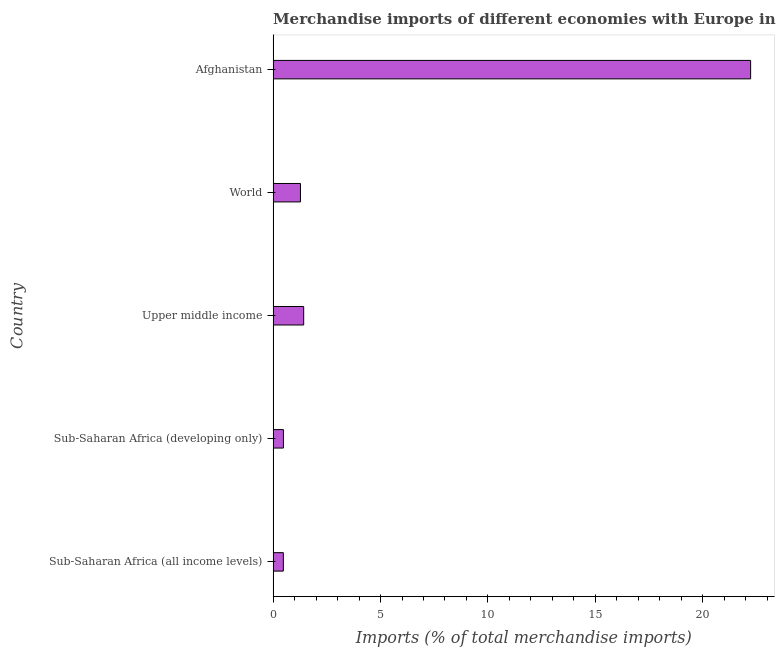Does the graph contain grids?
Provide a short and direct response. No. What is the title of the graph?
Your answer should be very brief. Merchandise imports of different economies with Europe in 2000. What is the label or title of the X-axis?
Your response must be concise. Imports (% of total merchandise imports). What is the merchandise imports in Sub-Saharan Africa (developing only)?
Offer a very short reply. 0.48. Across all countries, what is the maximum merchandise imports?
Your answer should be very brief. 22.23. Across all countries, what is the minimum merchandise imports?
Offer a terse response. 0.48. In which country was the merchandise imports maximum?
Keep it short and to the point. Afghanistan. In which country was the merchandise imports minimum?
Your response must be concise. Sub-Saharan Africa (all income levels). What is the sum of the merchandise imports?
Keep it short and to the point. 25.88. What is the difference between the merchandise imports in Sub-Saharan Africa (developing only) and Upper middle income?
Give a very brief answer. -0.94. What is the average merchandise imports per country?
Your answer should be very brief. 5.18. What is the median merchandise imports?
Make the answer very short. 1.27. In how many countries, is the merchandise imports greater than 13 %?
Provide a short and direct response. 1. What is the ratio of the merchandise imports in Afghanistan to that in World?
Make the answer very short. 17.47. Is the merchandise imports in Sub-Saharan Africa (developing only) less than that in Upper middle income?
Your response must be concise. Yes. Is the difference between the merchandise imports in Sub-Saharan Africa (developing only) and World greater than the difference between any two countries?
Offer a very short reply. No. What is the difference between the highest and the second highest merchandise imports?
Provide a short and direct response. 20.81. What is the difference between the highest and the lowest merchandise imports?
Keep it short and to the point. 21.75. In how many countries, is the merchandise imports greater than the average merchandise imports taken over all countries?
Offer a very short reply. 1. How many bars are there?
Give a very brief answer. 5. What is the Imports (% of total merchandise imports) in Sub-Saharan Africa (all income levels)?
Make the answer very short. 0.48. What is the Imports (% of total merchandise imports) of Sub-Saharan Africa (developing only)?
Make the answer very short. 0.48. What is the Imports (% of total merchandise imports) of Upper middle income?
Your answer should be very brief. 1.42. What is the Imports (% of total merchandise imports) of World?
Give a very brief answer. 1.27. What is the Imports (% of total merchandise imports) of Afghanistan?
Make the answer very short. 22.23. What is the difference between the Imports (% of total merchandise imports) in Sub-Saharan Africa (all income levels) and Sub-Saharan Africa (developing only)?
Your answer should be very brief. -0. What is the difference between the Imports (% of total merchandise imports) in Sub-Saharan Africa (all income levels) and Upper middle income?
Give a very brief answer. -0.95. What is the difference between the Imports (% of total merchandise imports) in Sub-Saharan Africa (all income levels) and World?
Give a very brief answer. -0.8. What is the difference between the Imports (% of total merchandise imports) in Sub-Saharan Africa (all income levels) and Afghanistan?
Offer a very short reply. -21.75. What is the difference between the Imports (% of total merchandise imports) in Sub-Saharan Africa (developing only) and Upper middle income?
Ensure brevity in your answer.  -0.94. What is the difference between the Imports (% of total merchandise imports) in Sub-Saharan Africa (developing only) and World?
Make the answer very short. -0.79. What is the difference between the Imports (% of total merchandise imports) in Sub-Saharan Africa (developing only) and Afghanistan?
Make the answer very short. -21.75. What is the difference between the Imports (% of total merchandise imports) in Upper middle income and World?
Offer a very short reply. 0.15. What is the difference between the Imports (% of total merchandise imports) in Upper middle income and Afghanistan?
Offer a terse response. -20.81. What is the difference between the Imports (% of total merchandise imports) in World and Afghanistan?
Ensure brevity in your answer.  -20.96. What is the ratio of the Imports (% of total merchandise imports) in Sub-Saharan Africa (all income levels) to that in Sub-Saharan Africa (developing only)?
Provide a succinct answer. 0.99. What is the ratio of the Imports (% of total merchandise imports) in Sub-Saharan Africa (all income levels) to that in Upper middle income?
Your answer should be compact. 0.33. What is the ratio of the Imports (% of total merchandise imports) in Sub-Saharan Africa (all income levels) to that in World?
Offer a very short reply. 0.37. What is the ratio of the Imports (% of total merchandise imports) in Sub-Saharan Africa (all income levels) to that in Afghanistan?
Offer a terse response. 0.02. What is the ratio of the Imports (% of total merchandise imports) in Sub-Saharan Africa (developing only) to that in Upper middle income?
Offer a terse response. 0.34. What is the ratio of the Imports (% of total merchandise imports) in Sub-Saharan Africa (developing only) to that in World?
Give a very brief answer. 0.38. What is the ratio of the Imports (% of total merchandise imports) in Sub-Saharan Africa (developing only) to that in Afghanistan?
Offer a very short reply. 0.02. What is the ratio of the Imports (% of total merchandise imports) in Upper middle income to that in World?
Your response must be concise. 1.12. What is the ratio of the Imports (% of total merchandise imports) in Upper middle income to that in Afghanistan?
Your response must be concise. 0.06. What is the ratio of the Imports (% of total merchandise imports) in World to that in Afghanistan?
Provide a short and direct response. 0.06. 